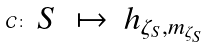Convert formula to latex. <formula><loc_0><loc_0><loc_500><loc_500>\mathcal { C } \colon \begin{array} { l c l } S & \mapsto & h _ { \zeta _ { S } , m _ { \zeta _ { S } } } \end{array}</formula> 